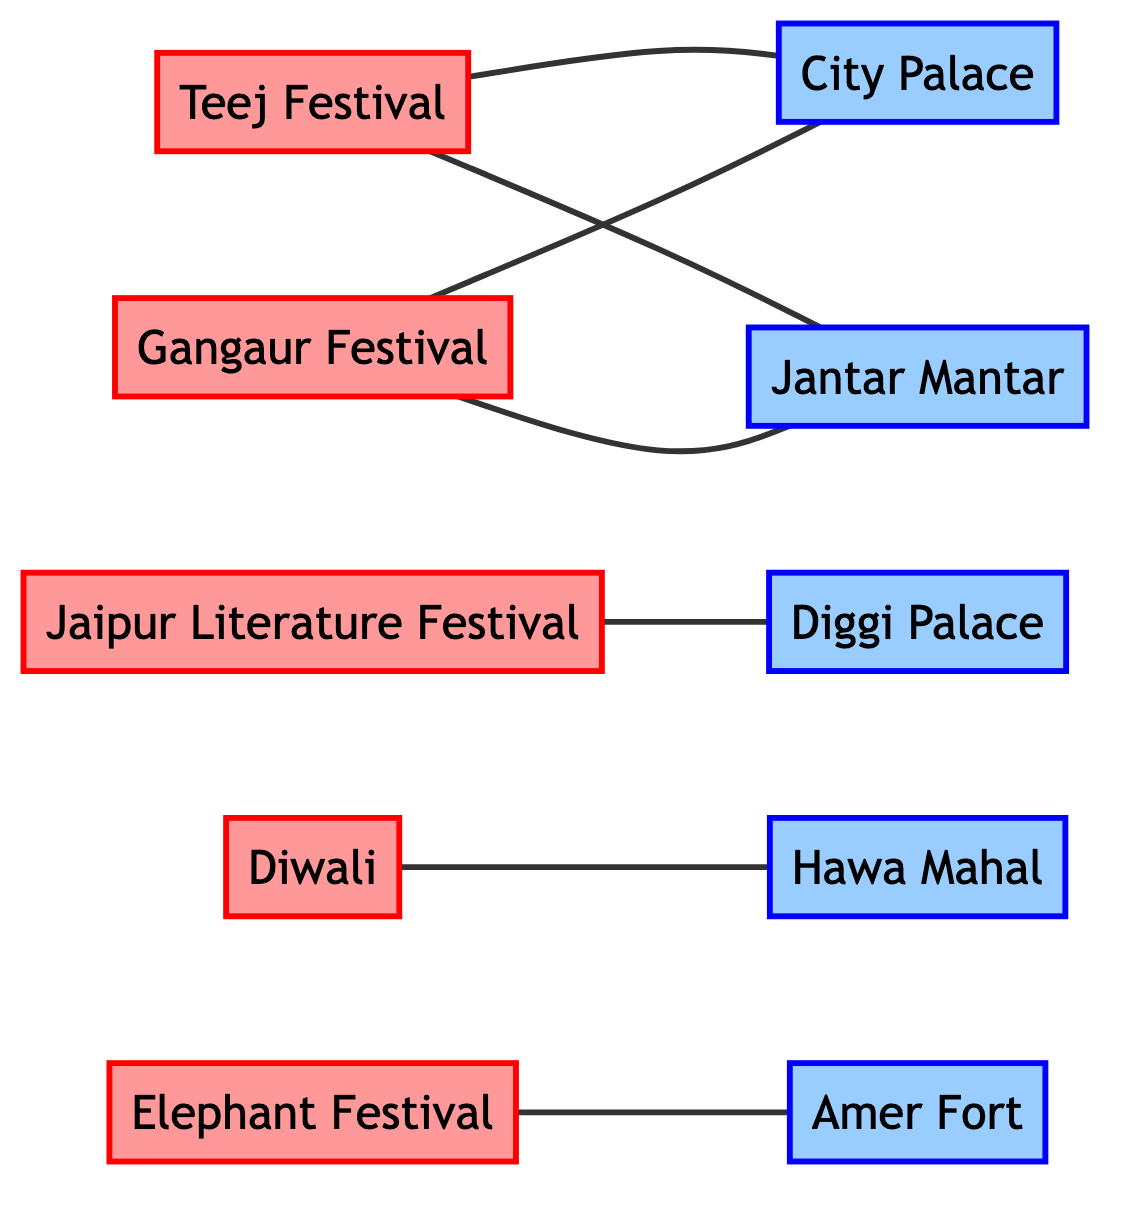What is the key location for the Teej Festival? The diagram shows an edge connecting "Teej Festival" to "City Palace", indicating that the festival is held at this location.
Answer: City Palace Which festival is associated with Hawa Mahal? The diagram identifies a connection between "Diwali" and "Hawa Mahal", establishing that the festival is linked to this location.
Answer: Diwali How many festivals are shown in the diagram? By counting the festival nodes in the diagram, we find five distinct festivals: Teej Festival, Gangaur Festival, Jaipur Literature Festival, Diwali, and Elephant Festival.
Answer: 5 What two festivals have a procession at Jantar Mantar? The diagram reveals that both "Teej Festival" and "Gangaur Festival" have edges connecting them to "Jantar Mantar", indicating they feature a procession there.
Answer: Teej Festival, Gangaur Festival Which festival is held at Diggi Palace? According to the diagram, the "Jaipur Literature Festival" has a direct connection to "Diggi Palace", indicating that it is held at this location.
Answer: Jaipur Literature Festival What are the two key locations for the Gangaur Festival? The diagram shows connections from "Gangaur Festival" to both "City Palace" and "Jantar Mantar", indicating that the festival is associated with these two key locations.
Answer: City Palace, Jantar Mantar Which festival is held at Amer Fort? The diagram specifies that the "Elephant Festival" is the festival that has a connection to "Amer Fort", indicating it is held there.
Answer: Elephant Festival Name one location associated with Diwali. The diagram illustrates a link from "Diwali" to "Hawa Mahal", establishing that this location is associated with the festival.
Answer: Hawa Mahal 